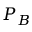Convert formula to latex. <formula><loc_0><loc_0><loc_500><loc_500>P _ { B }</formula> 